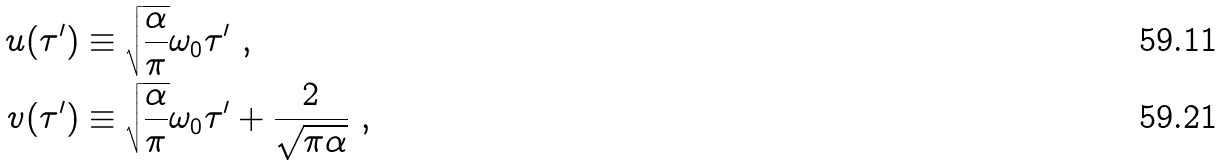<formula> <loc_0><loc_0><loc_500><loc_500>u ( \tau ^ { \prime } ) & \equiv \sqrt { \frac { \alpha } { \pi } } \omega _ { 0 } \tau ^ { \prime } \ , \\ v ( \tau ^ { \prime } ) & \equiv \sqrt { \frac { \alpha } { \pi } } \omega _ { 0 } \tau ^ { \prime } + \frac { 2 } { \sqrt { \pi \alpha } } \ ,</formula> 